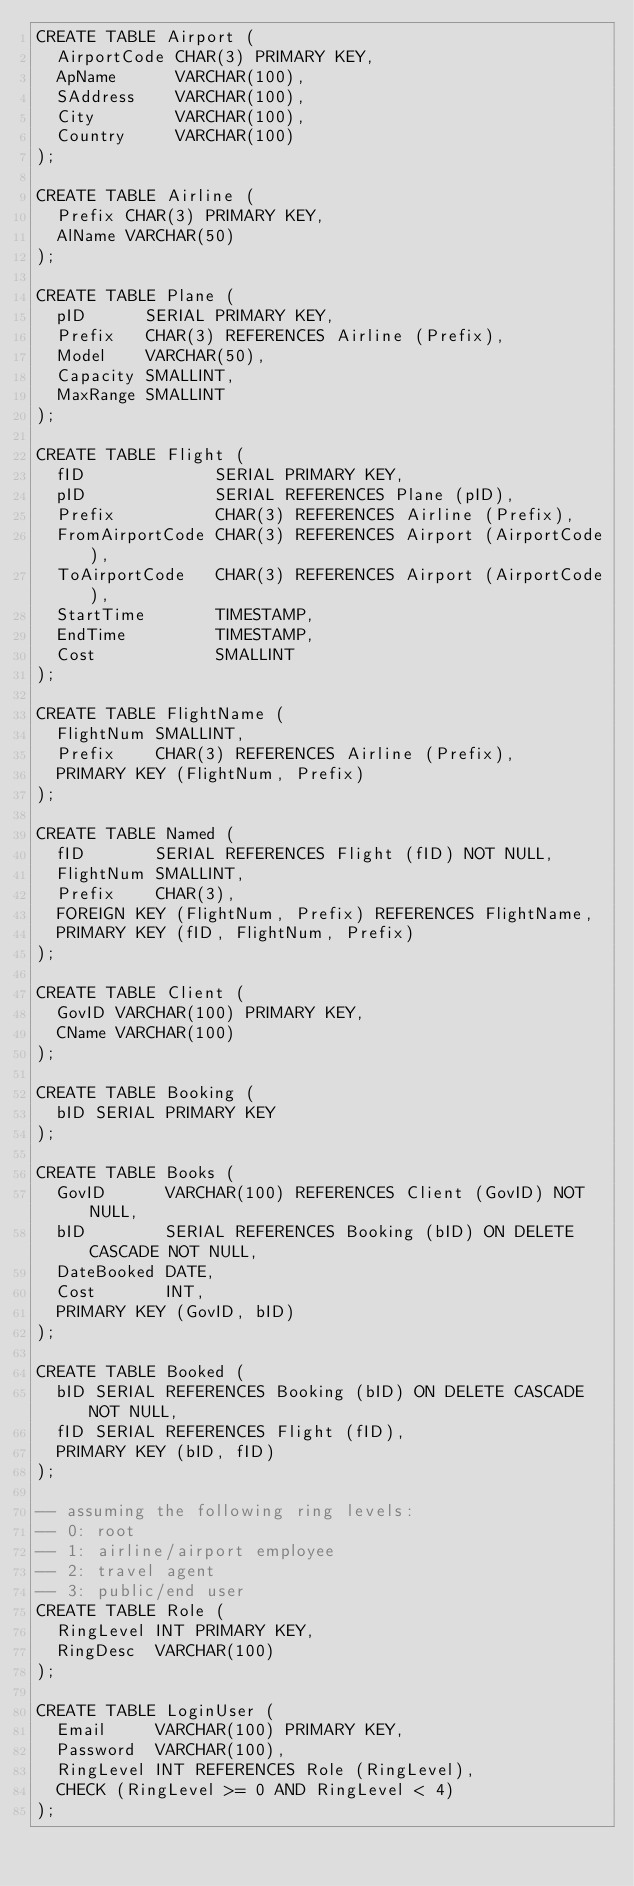Convert code to text. <code><loc_0><loc_0><loc_500><loc_500><_SQL_>CREATE TABLE Airport (
  AirportCode CHAR(3) PRIMARY KEY,
  ApName      VARCHAR(100),
  SAddress    VARCHAR(100),
  City        VARCHAR(100),
  Country     VARCHAR(100)
);

CREATE TABLE Airline (
  Prefix CHAR(3) PRIMARY KEY,
  AlName VARCHAR(50)
);

CREATE TABLE Plane (
  pID      SERIAL PRIMARY KEY,
  Prefix   CHAR(3) REFERENCES Airline (Prefix),
  Model    VARCHAR(50),
  Capacity SMALLINT,
  MaxRange SMALLINT
);

CREATE TABLE Flight (
  fID             SERIAL PRIMARY KEY,
  pID             SERIAL REFERENCES Plane (pID),
  Prefix          CHAR(3) REFERENCES Airline (Prefix),
  FromAirportCode CHAR(3) REFERENCES Airport (AirportCode),
  ToAirportCode   CHAR(3) REFERENCES Airport (AirportCode),
  StartTime       TIMESTAMP,
  EndTime         TIMESTAMP,
  Cost            SMALLINT
);

CREATE TABLE FlightName (
  FlightNum SMALLINT,
  Prefix    CHAR(3) REFERENCES Airline (Prefix),
  PRIMARY KEY (FlightNum, Prefix)
);

CREATE TABLE Named (
  fID       SERIAL REFERENCES Flight (fID) NOT NULL,
  FlightNum SMALLINT,
  Prefix    CHAR(3),
  FOREIGN KEY (FlightNum, Prefix) REFERENCES FlightName,
  PRIMARY KEY (fID, FlightNum, Prefix)
);

CREATE TABLE Client (
  GovID VARCHAR(100) PRIMARY KEY,
  CName VARCHAR(100)
);

CREATE TABLE Booking (
  bID SERIAL PRIMARY KEY
);

CREATE TABLE Books (
  GovID      VARCHAR(100) REFERENCES Client (GovID) NOT NULL,
  bID        SERIAL REFERENCES Booking (bID) ON DELETE CASCADE NOT NULL,
  DateBooked DATE,
  Cost       INT,
  PRIMARY KEY (GovID, bID)
);

CREATE TABLE Booked (
  bID SERIAL REFERENCES Booking (bID) ON DELETE CASCADE NOT NULL,
  fID SERIAL REFERENCES Flight (fID),
  PRIMARY KEY (bID, fID)
);

-- assuming the following ring levels:
-- 0: root
-- 1: airline/airport employee
-- 2: travel agent
-- 3: public/end user
CREATE TABLE Role (
  RingLevel INT PRIMARY KEY,
  RingDesc  VARCHAR(100)
);

CREATE TABLE LoginUser (
  Email     VARCHAR(100) PRIMARY KEY,
  Password  VARCHAR(100),
  RingLevel INT REFERENCES Role (RingLevel),
  CHECK (RingLevel >= 0 AND RingLevel < 4)
);
</code> 